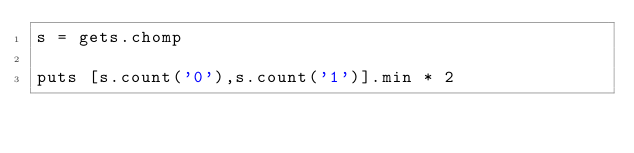<code> <loc_0><loc_0><loc_500><loc_500><_Ruby_>s = gets.chomp

puts [s.count('0'),s.count('1')].min * 2</code> 